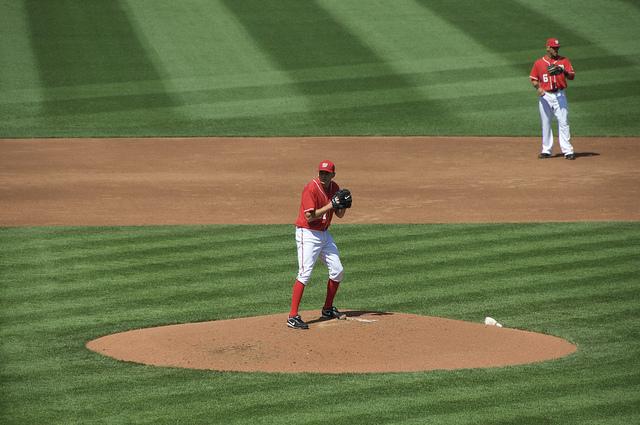Is there an umpire?
Short answer required. No. What is the pitcher standing on?
Write a very short answer. Mound. Which sport is this?
Be succinct. Baseball. How many players on the field?
Answer briefly. 2. Who is wearing the red socks?
Quick response, please. Pitcher. What color are the lines?
Answer briefly. Green. Is the pitcher holding the ball?
Give a very brief answer. Yes. What color is the last man pants?
Write a very short answer. White. How many infield players are shown?
Answer briefly. 2. 